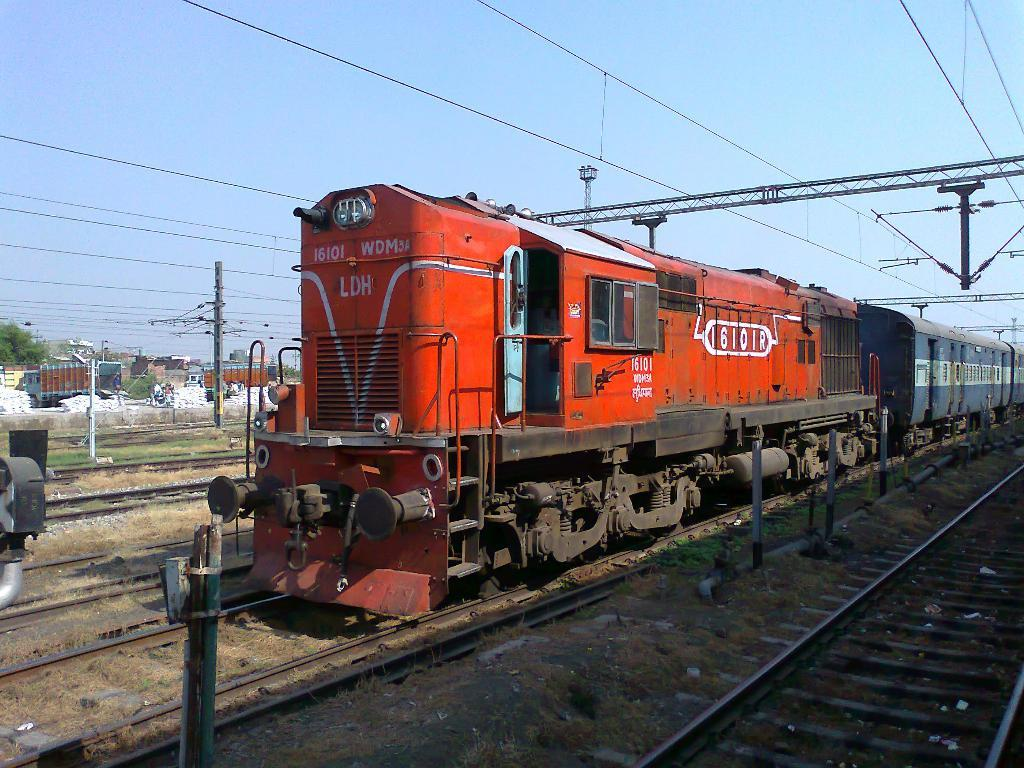<image>
Provide a brief description of the given image. A red train that has the number 16101 on the very front. 